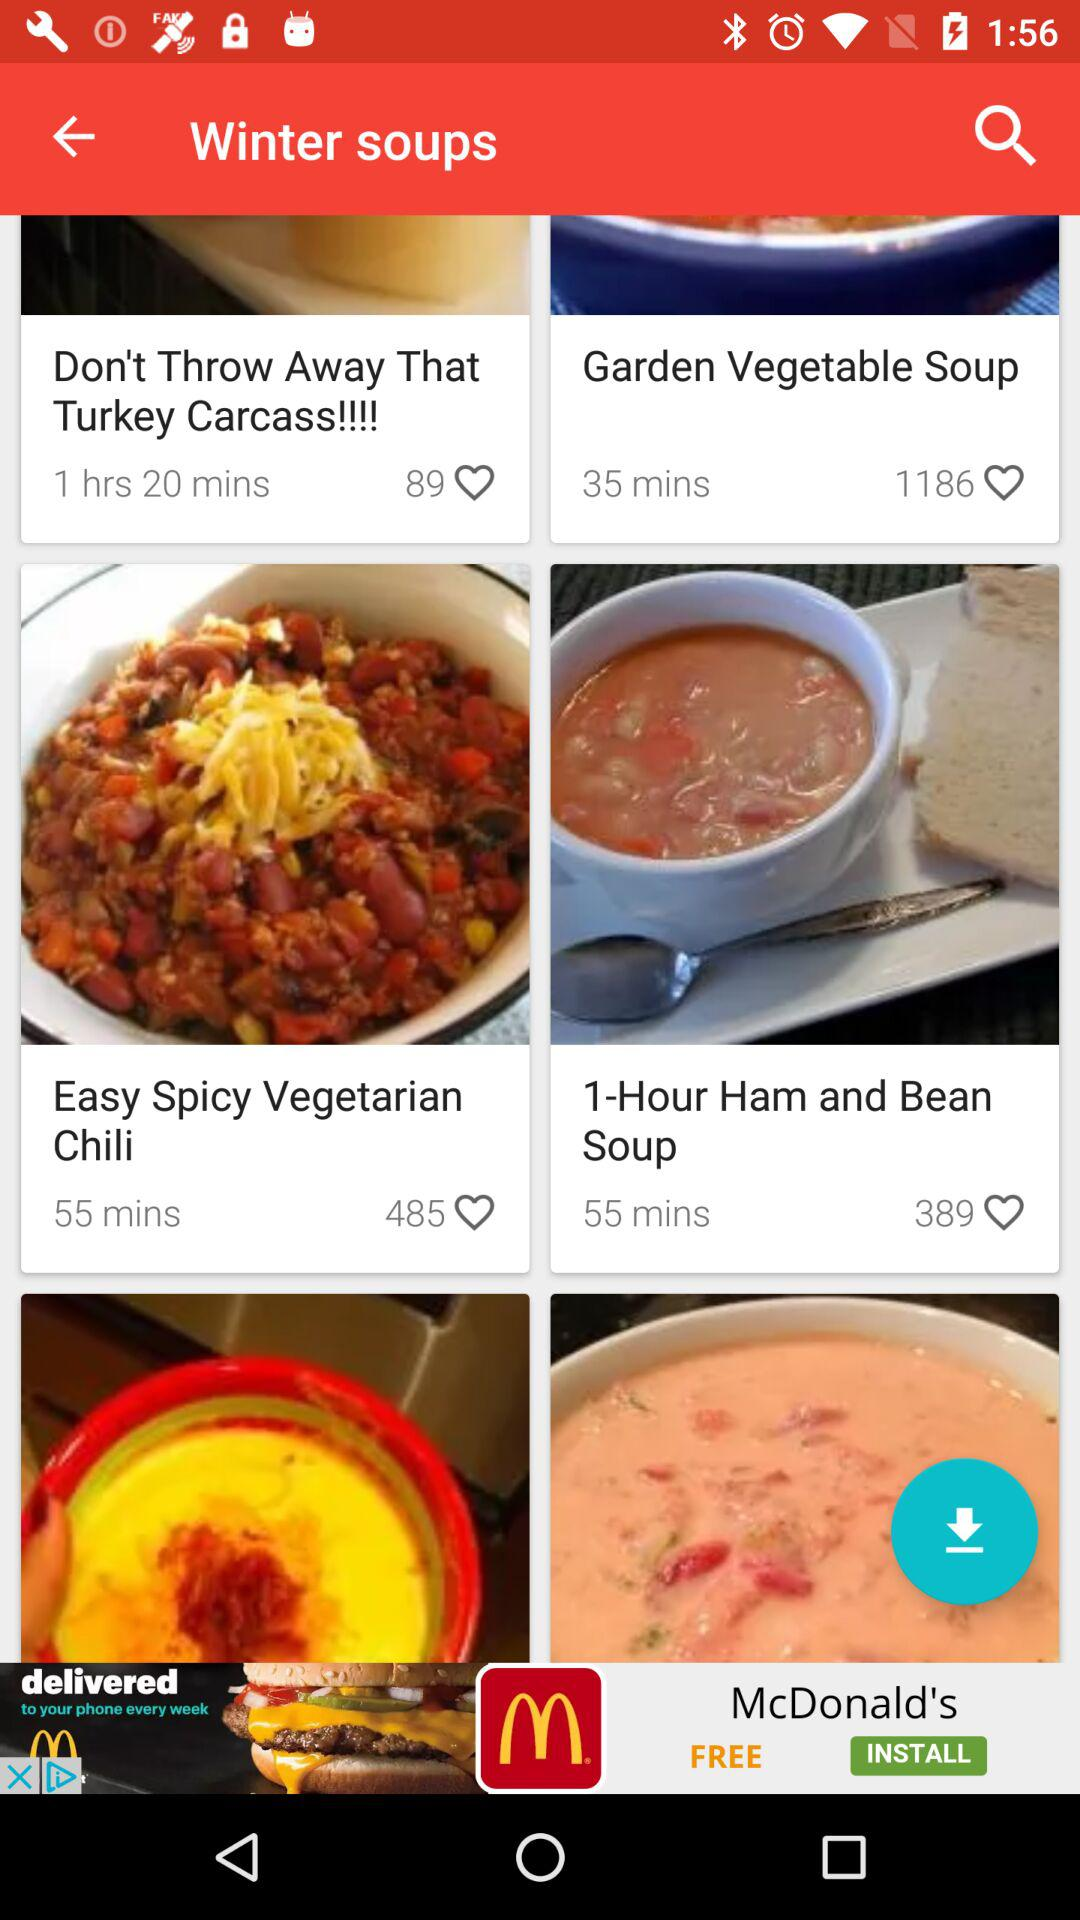What is the given time of "1-Hour Ham and Bean Soup"? The given time of "1-Hour Ham and Bean Soup" is 55 minutes. 